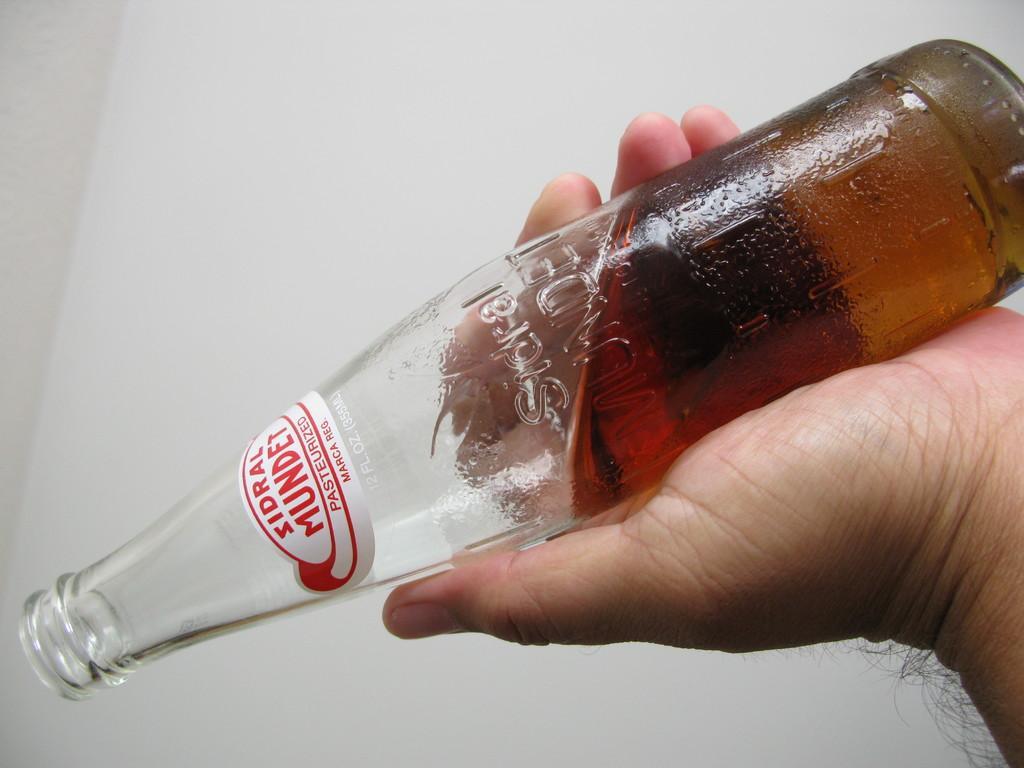How would you summarize this image in a sentence or two? In this image i can see a bottle and a human hand. 